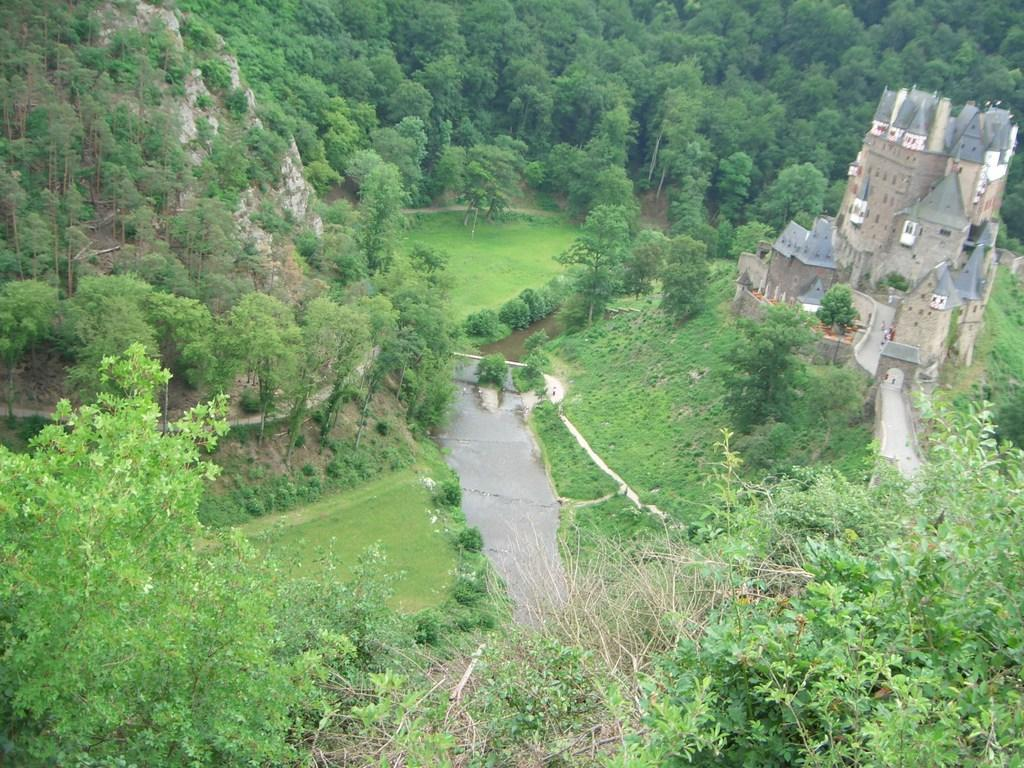What type of surface can be seen in the image? There is a road in the image. What type of structure is present in the image? There is a fort in the image. What type of path is visible in the image? There is a path in the image. What type of vegetation is present in the image? There is grass in the image. What can be seen in the background of the image? There are trees in the background of the image. What type of wool is being used to knit a sweater in the image? There is no wool or sweater present in the image. What type of class is being held in the image? There is no class or educational setting present in the image. 